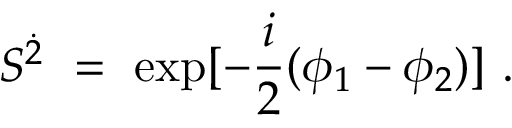<formula> <loc_0><loc_0><loc_500><loc_500>S ^ { \dot { 2 } } = e x p [ - \frac { i } { 2 } ( \phi _ { 1 } - \phi _ { 2 } ) ] .</formula> 